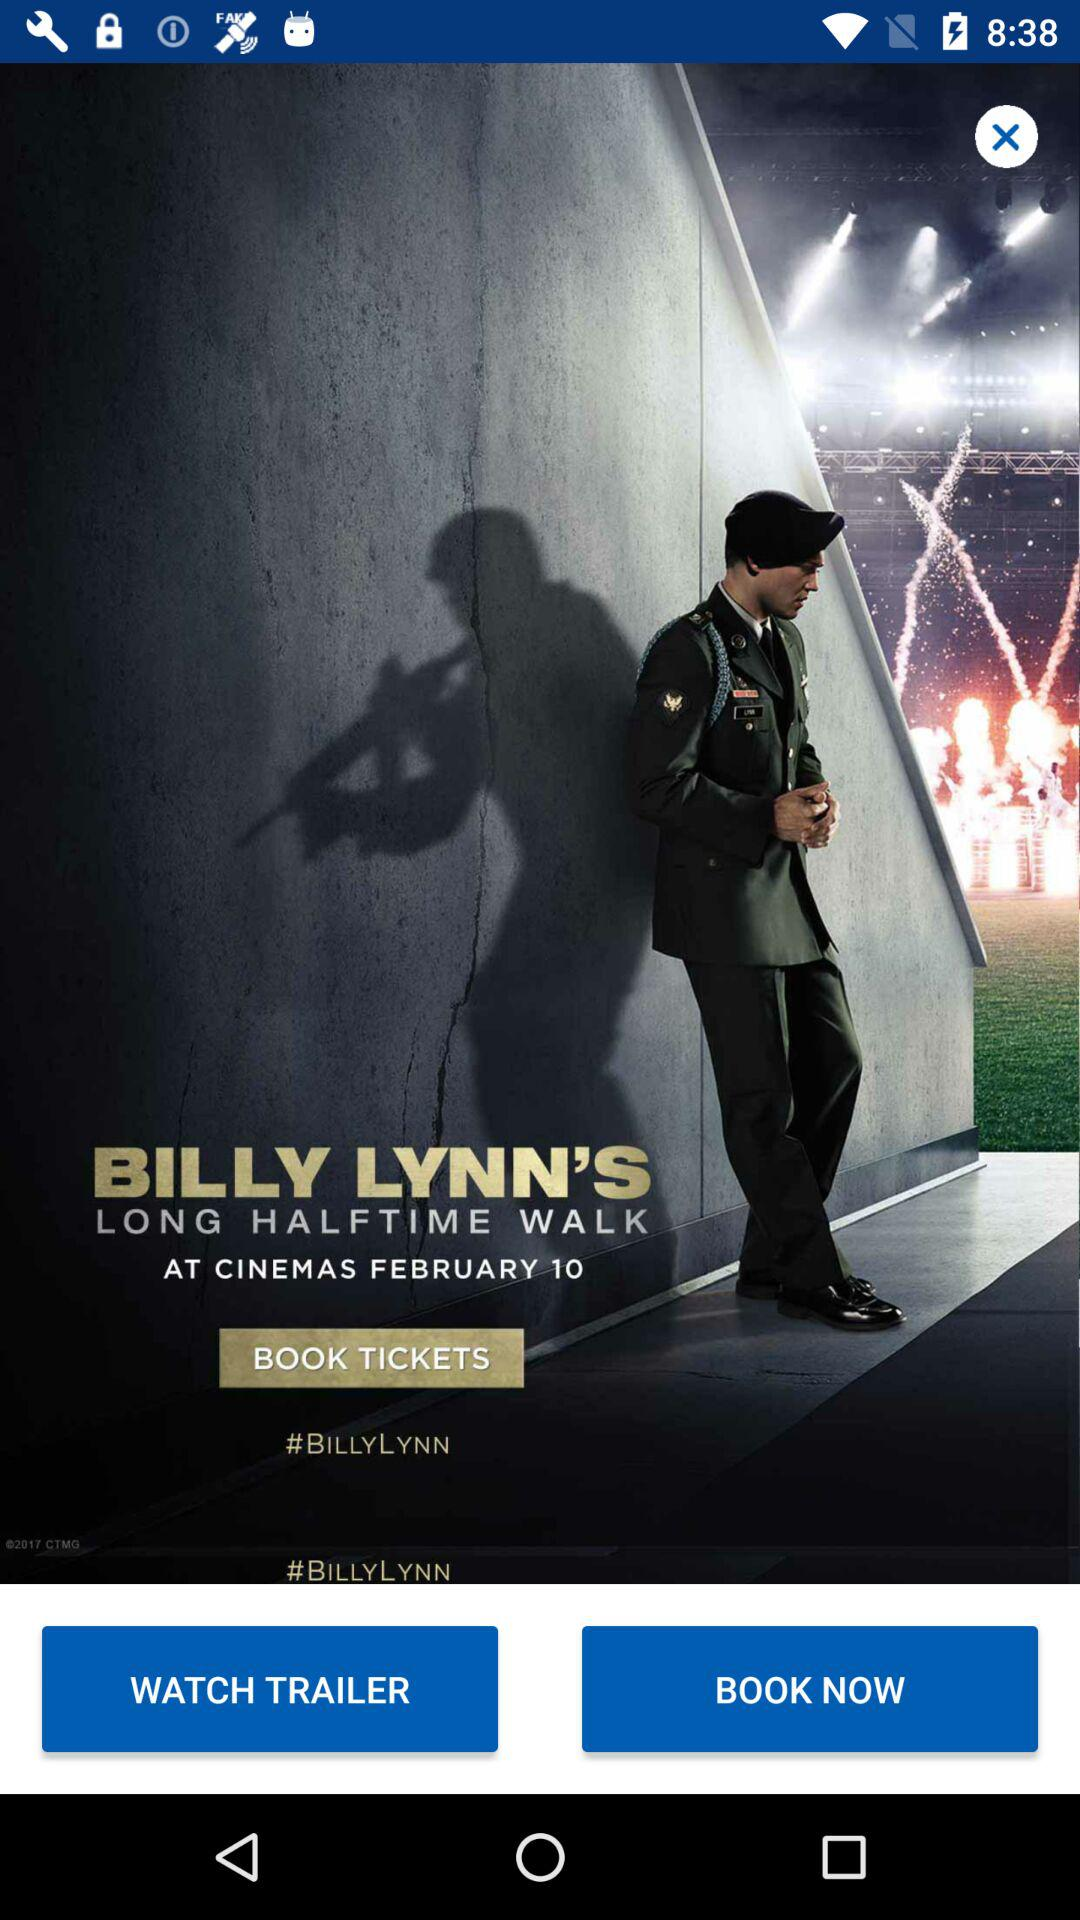What is the name of the movie? The name of the movie is "BILLY LYNN'S LONG HALFTIME WALK". 